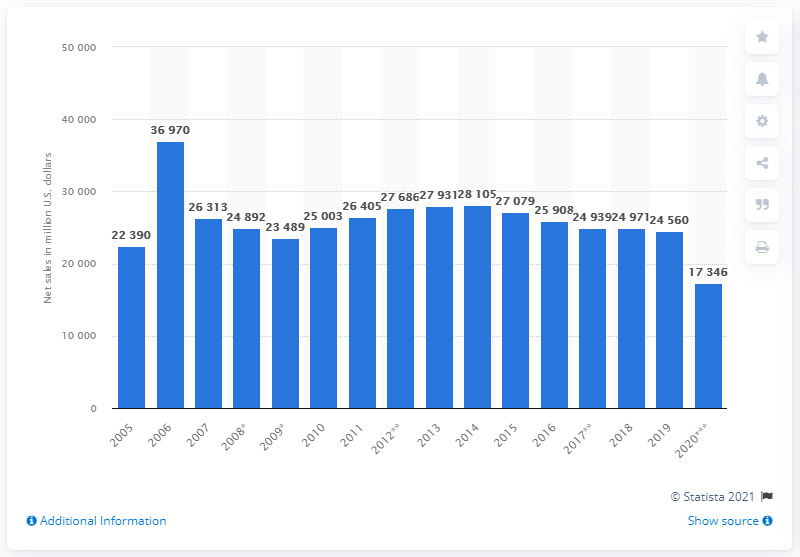Point out several critical features in this image. In 2020, Macy's global net sales amounted to approximately 17,346 dollars. In 2018, Macy's net sales were approximately 24,560. 